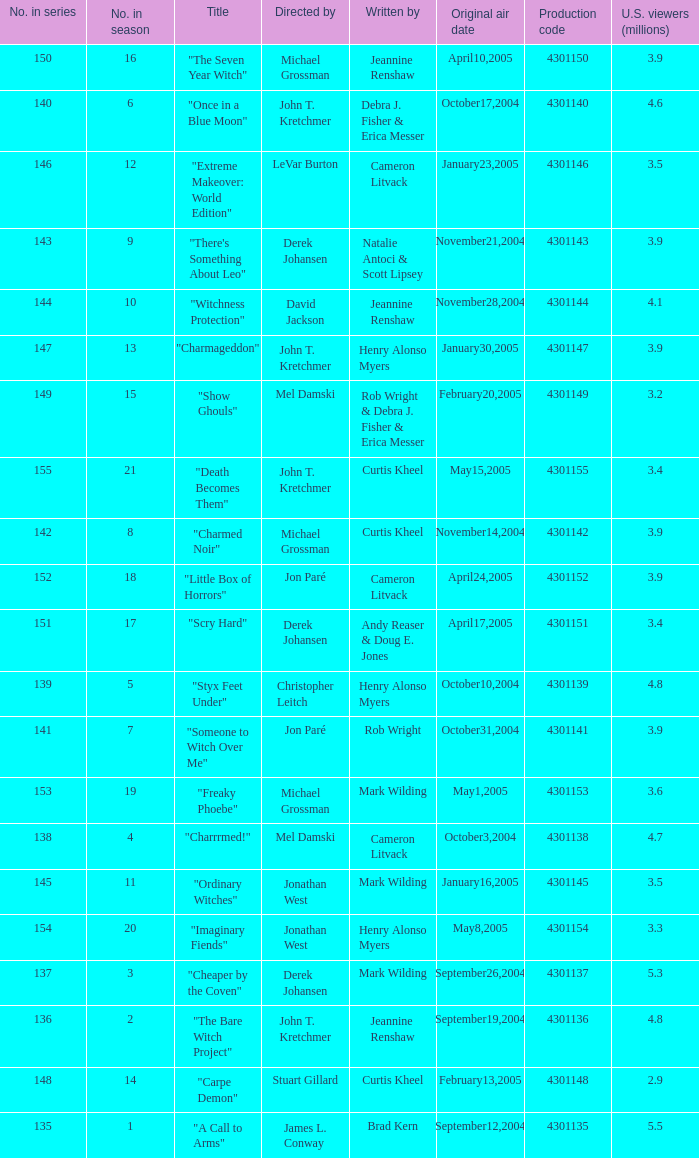Who were the directors of the episode called "someone to witch over me"? Jon Paré. 